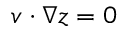<formula> <loc_0><loc_0><loc_500><loc_500>v \cdot \nabla z = 0</formula> 